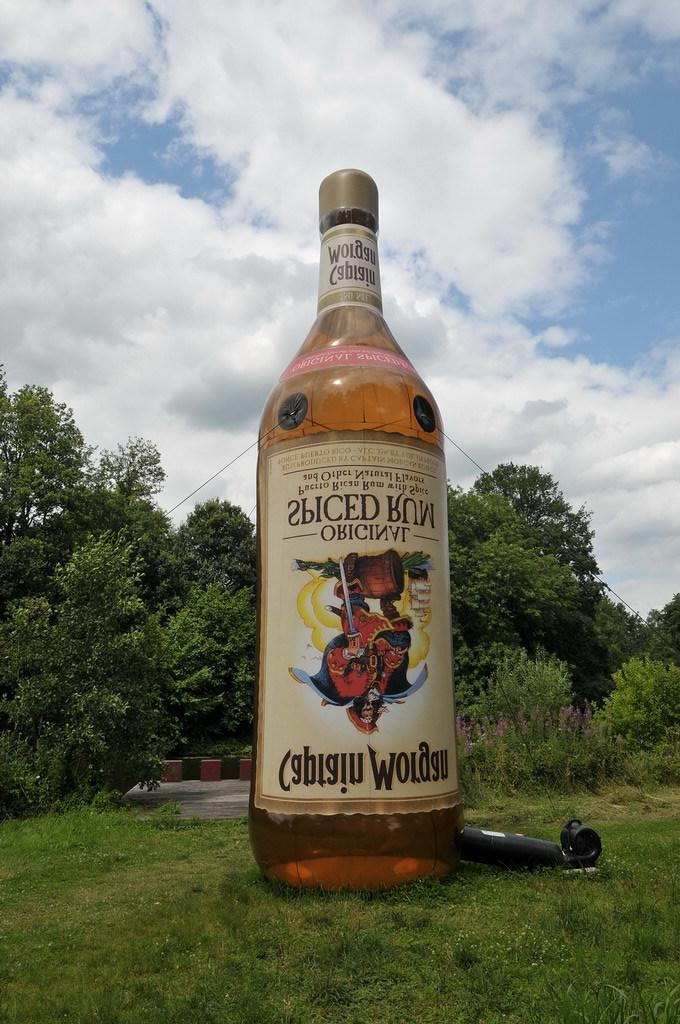<image>
Summarize the visual content of the image. A huge Captain Morgan balloon grounded in the field. 